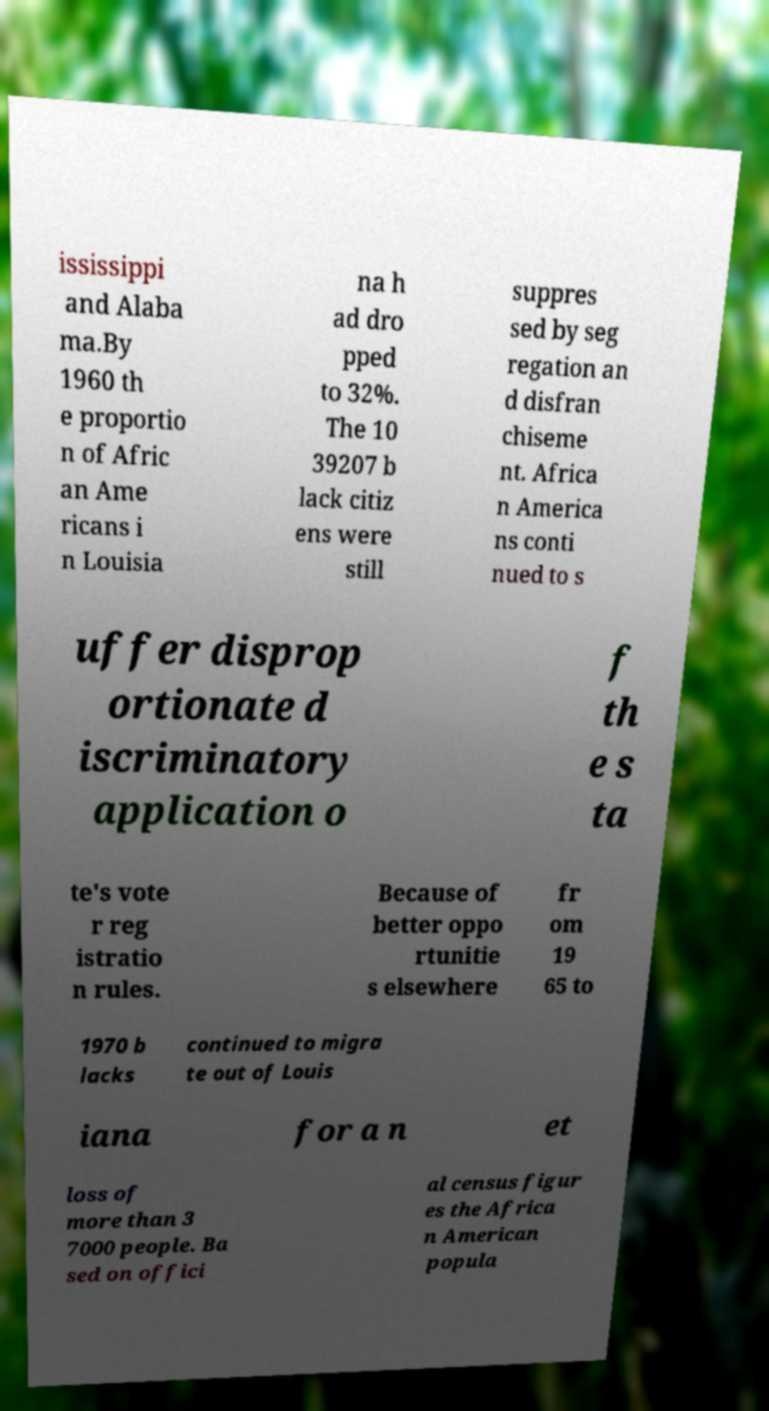Please read and relay the text visible in this image. What does it say? ississippi and Alaba ma.By 1960 th e proportio n of Afric an Ame ricans i n Louisia na h ad dro pped to 32%. The 10 39207 b lack citiz ens were still suppres sed by seg regation an d disfran chiseme nt. Africa n America ns conti nued to s uffer disprop ortionate d iscriminatory application o f th e s ta te's vote r reg istratio n rules. Because of better oppo rtunitie s elsewhere fr om 19 65 to 1970 b lacks continued to migra te out of Louis iana for a n et loss of more than 3 7000 people. Ba sed on offici al census figur es the Africa n American popula 